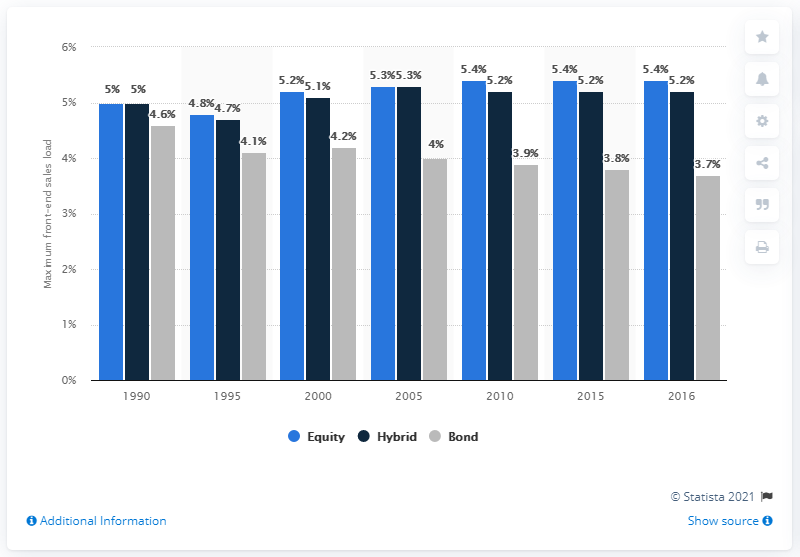Mention a couple of crucial points in this snapshot. It is unclear which option has the highest value based on the information provided. The year with the least sum among the given years is 1995. The maximum front-end sales load charged by equity funds in 2016 was 5.4%. 